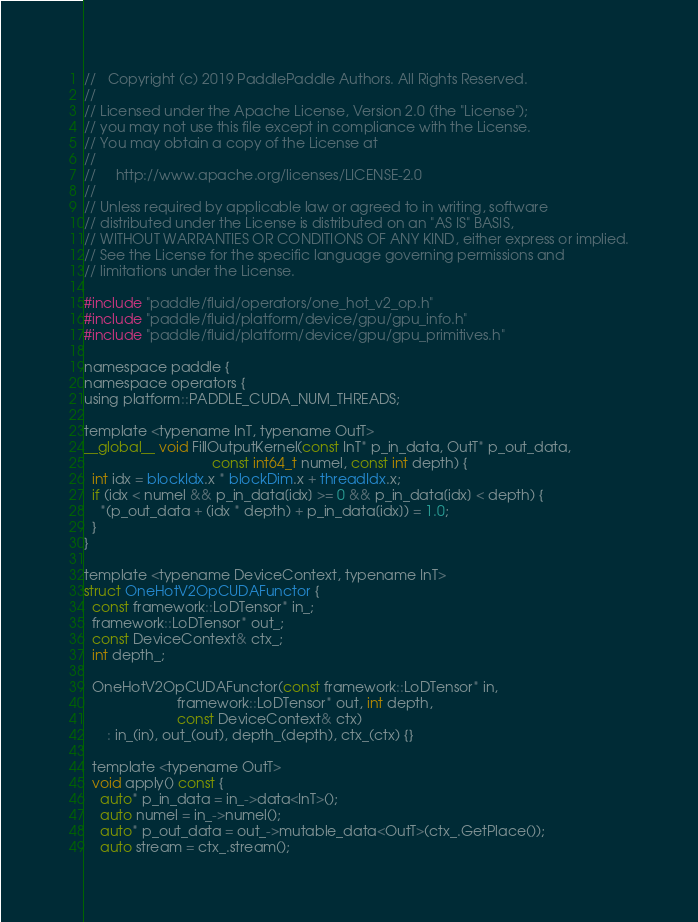Convert code to text. <code><loc_0><loc_0><loc_500><loc_500><_Cuda_>//   Copyright (c) 2019 PaddlePaddle Authors. All Rights Reserved.
//
// Licensed under the Apache License, Version 2.0 (the "License");
// you may not use this file except in compliance with the License.
// You may obtain a copy of the License at
//
//     http://www.apache.org/licenses/LICENSE-2.0
//
// Unless required by applicable law or agreed to in writing, software
// distributed under the License is distributed on an "AS IS" BASIS,
// WITHOUT WARRANTIES OR CONDITIONS OF ANY KIND, either express or implied.
// See the License for the specific language governing permissions and
// limitations under the License.

#include "paddle/fluid/operators/one_hot_v2_op.h"
#include "paddle/fluid/platform/device/gpu/gpu_info.h"
#include "paddle/fluid/platform/device/gpu/gpu_primitives.h"

namespace paddle {
namespace operators {
using platform::PADDLE_CUDA_NUM_THREADS;

template <typename InT, typename OutT>
__global__ void FillOutputKernel(const InT* p_in_data, OutT* p_out_data,
                                 const int64_t numel, const int depth) {
  int idx = blockIdx.x * blockDim.x + threadIdx.x;
  if (idx < numel && p_in_data[idx] >= 0 && p_in_data[idx] < depth) {
    *(p_out_data + (idx * depth) + p_in_data[idx]) = 1.0;
  }
}

template <typename DeviceContext, typename InT>
struct OneHotV2OpCUDAFunctor {
  const framework::LoDTensor* in_;
  framework::LoDTensor* out_;
  const DeviceContext& ctx_;
  int depth_;

  OneHotV2OpCUDAFunctor(const framework::LoDTensor* in,
                        framework::LoDTensor* out, int depth,
                        const DeviceContext& ctx)
      : in_(in), out_(out), depth_(depth), ctx_(ctx) {}

  template <typename OutT>
  void apply() const {
    auto* p_in_data = in_->data<InT>();
    auto numel = in_->numel();
    auto* p_out_data = out_->mutable_data<OutT>(ctx_.GetPlace());
    auto stream = ctx_.stream();</code> 